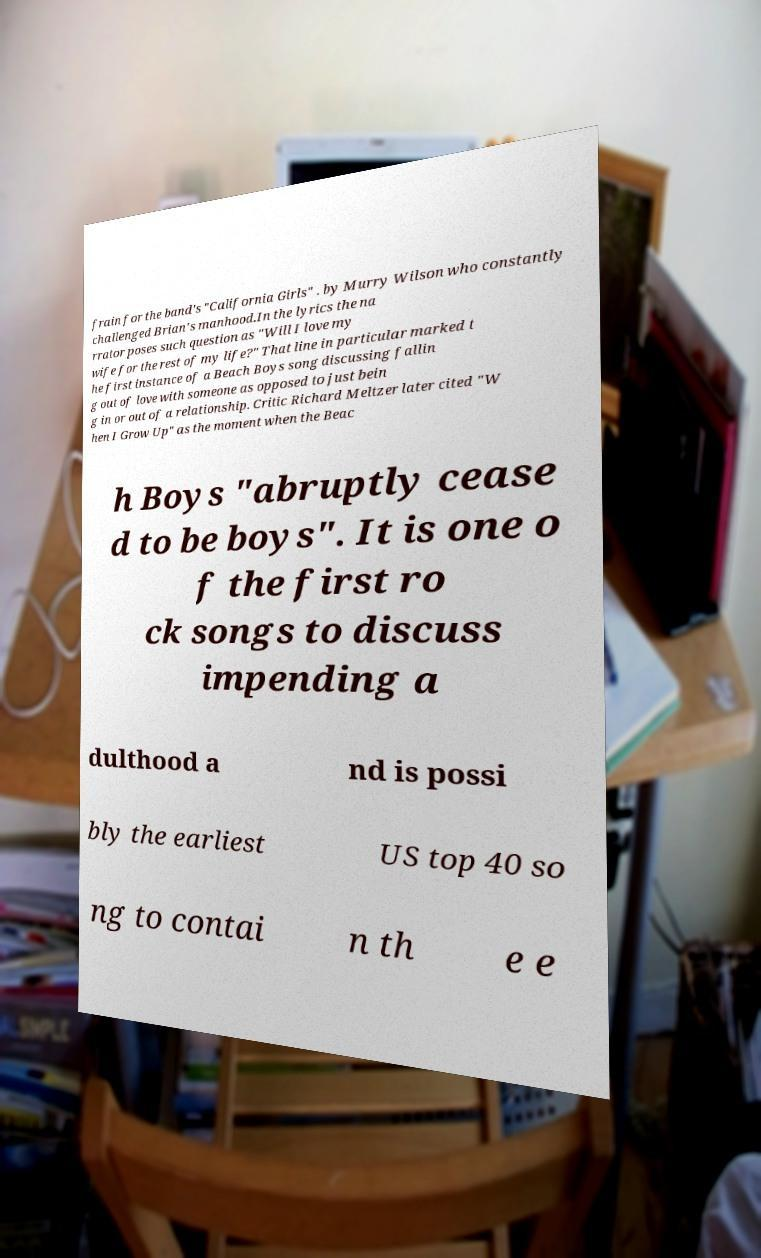Please read and relay the text visible in this image. What does it say? frain for the band's "California Girls" . by Murry Wilson who constantly challenged Brian's manhood.In the lyrics the na rrator poses such question as "Will I love my wife for the rest of my life?" That line in particular marked t he first instance of a Beach Boys song discussing fallin g out of love with someone as opposed to just bein g in or out of a relationship. Critic Richard Meltzer later cited "W hen I Grow Up" as the moment when the Beac h Boys "abruptly cease d to be boys". It is one o f the first ro ck songs to discuss impending a dulthood a nd is possi bly the earliest US top 40 so ng to contai n th e e 